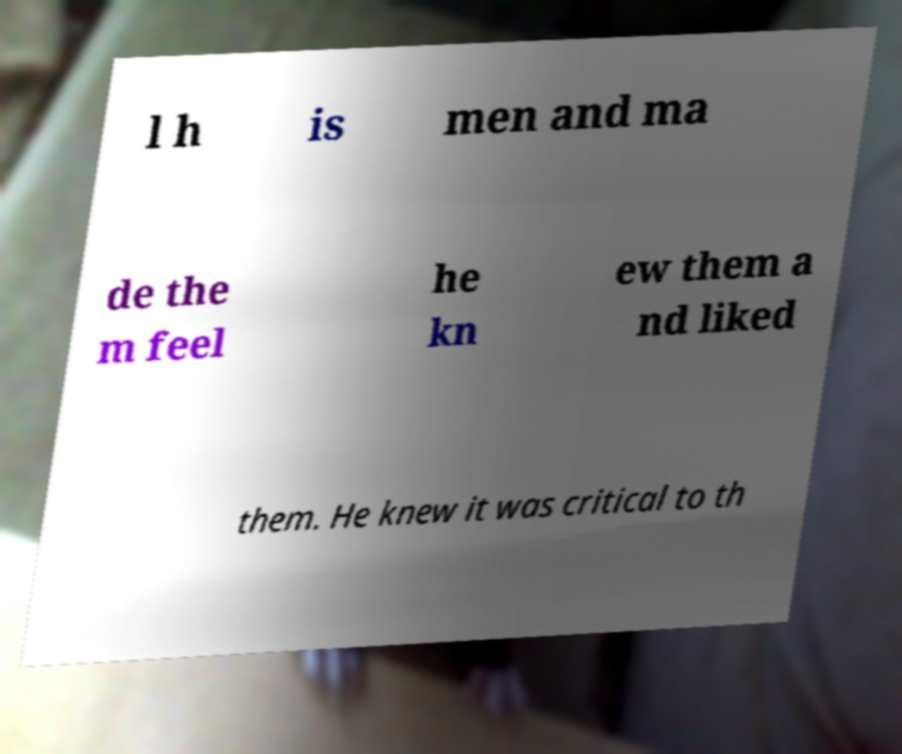What messages or text are displayed in this image? I need them in a readable, typed format. l h is men and ma de the m feel he kn ew them a nd liked them. He knew it was critical to th 